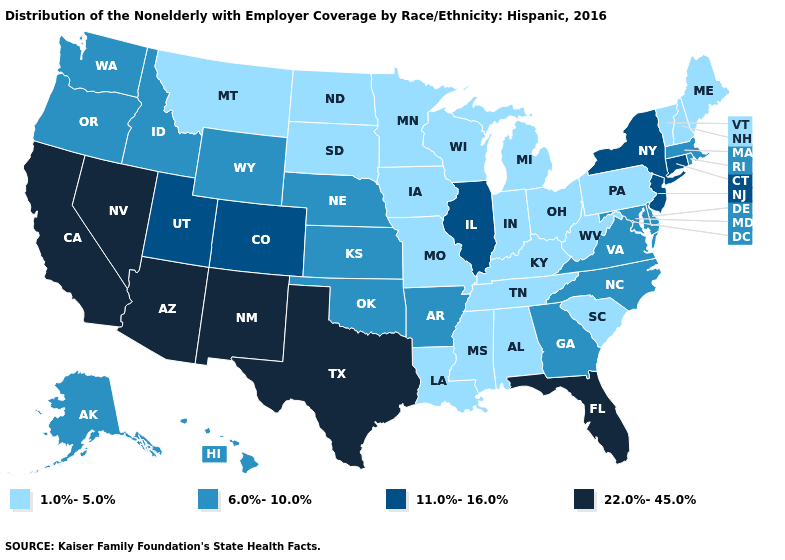What is the value of Kentucky?
Give a very brief answer. 1.0%-5.0%. Which states have the lowest value in the USA?
Keep it brief. Alabama, Indiana, Iowa, Kentucky, Louisiana, Maine, Michigan, Minnesota, Mississippi, Missouri, Montana, New Hampshire, North Dakota, Ohio, Pennsylvania, South Carolina, South Dakota, Tennessee, Vermont, West Virginia, Wisconsin. What is the value of Oklahoma?
Quick response, please. 6.0%-10.0%. Name the states that have a value in the range 1.0%-5.0%?
Give a very brief answer. Alabama, Indiana, Iowa, Kentucky, Louisiana, Maine, Michigan, Minnesota, Mississippi, Missouri, Montana, New Hampshire, North Dakota, Ohio, Pennsylvania, South Carolina, South Dakota, Tennessee, Vermont, West Virginia, Wisconsin. Among the states that border Wisconsin , which have the highest value?
Concise answer only. Illinois. How many symbols are there in the legend?
Give a very brief answer. 4. Does the first symbol in the legend represent the smallest category?
Keep it brief. Yes. Name the states that have a value in the range 1.0%-5.0%?
Give a very brief answer. Alabama, Indiana, Iowa, Kentucky, Louisiana, Maine, Michigan, Minnesota, Mississippi, Missouri, Montana, New Hampshire, North Dakota, Ohio, Pennsylvania, South Carolina, South Dakota, Tennessee, Vermont, West Virginia, Wisconsin. What is the value of Minnesota?
Write a very short answer. 1.0%-5.0%. What is the value of Massachusetts?
Write a very short answer. 6.0%-10.0%. Does South Carolina have the lowest value in the USA?
Quick response, please. Yes. Does the map have missing data?
Write a very short answer. No. Which states have the lowest value in the USA?
Keep it brief. Alabama, Indiana, Iowa, Kentucky, Louisiana, Maine, Michigan, Minnesota, Mississippi, Missouri, Montana, New Hampshire, North Dakota, Ohio, Pennsylvania, South Carolina, South Dakota, Tennessee, Vermont, West Virginia, Wisconsin. Name the states that have a value in the range 11.0%-16.0%?
Quick response, please. Colorado, Connecticut, Illinois, New Jersey, New York, Utah. Which states have the highest value in the USA?
Short answer required. Arizona, California, Florida, Nevada, New Mexico, Texas. 